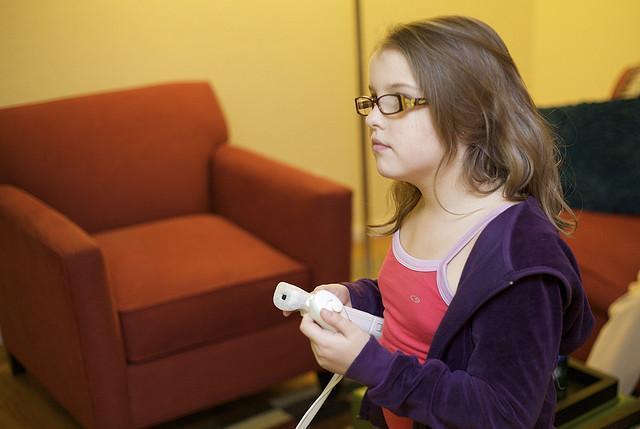How many young girls?
Give a very brief answer. 1. How many of the cows are calves?
Give a very brief answer. 0. 